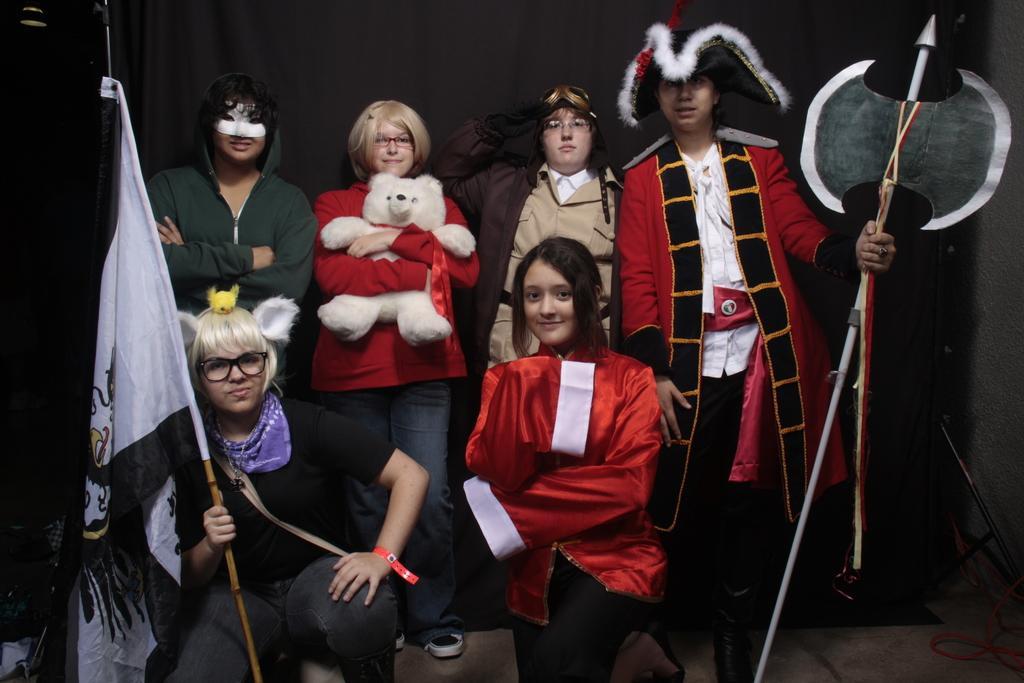How would you summarize this image in a sentence or two? In this image there are four persons standing, one of them is holding a doll in her hand, in front of the four persons there are two person's kneeled down, and one of the person is holding a flag in her hand. 